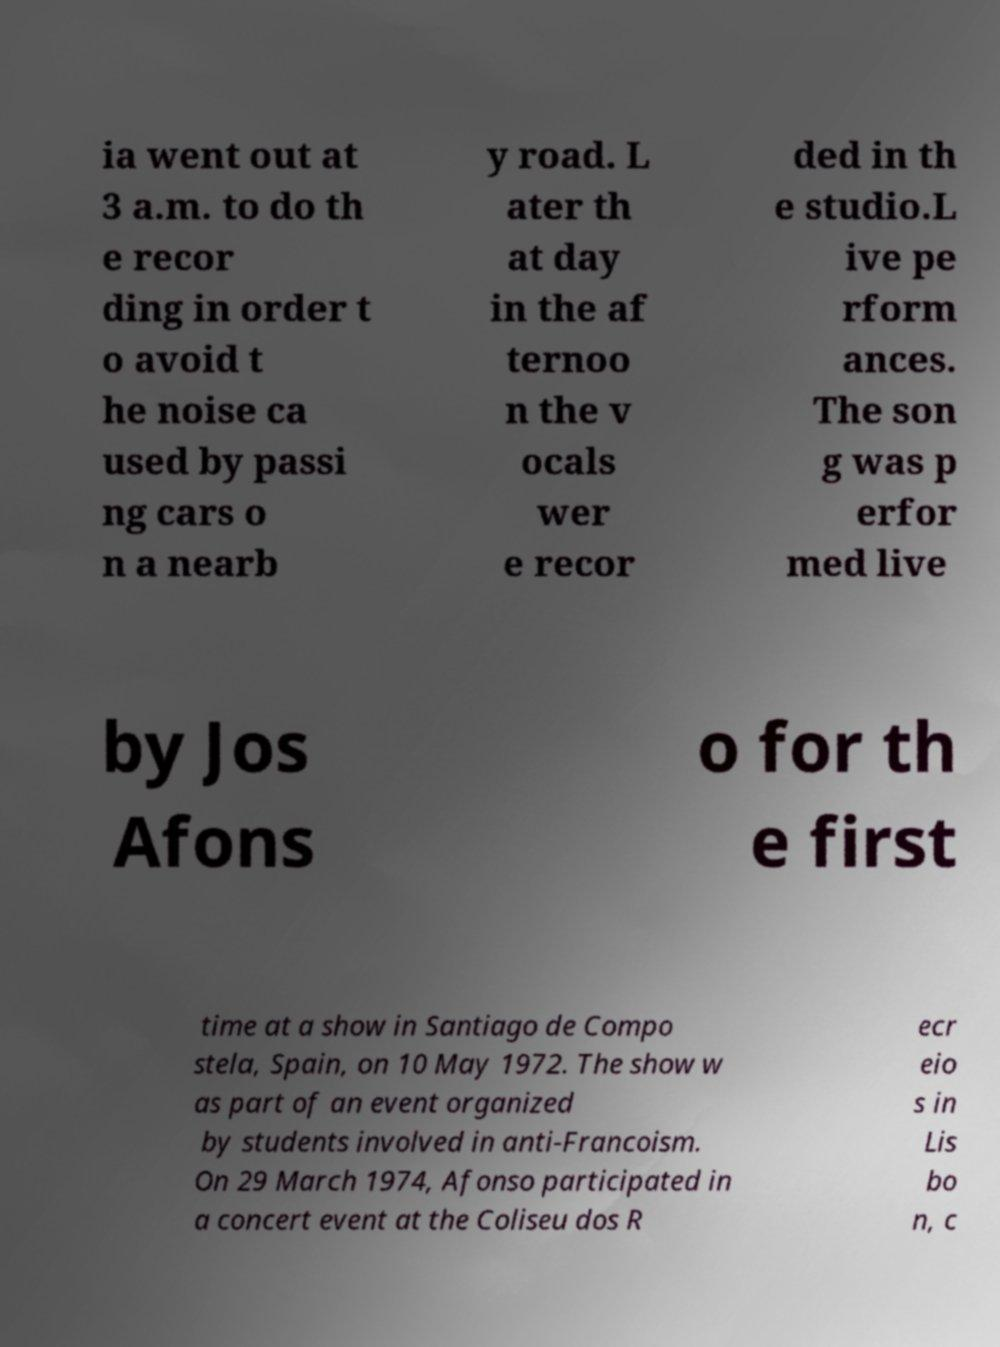Could you assist in decoding the text presented in this image and type it out clearly? ia went out at 3 a.m. to do th e recor ding in order t o avoid t he noise ca used by passi ng cars o n a nearb y road. L ater th at day in the af ternoo n the v ocals wer e recor ded in th e studio.L ive pe rform ances. The son g was p erfor med live by Jos Afons o for th e first time at a show in Santiago de Compo stela, Spain, on 10 May 1972. The show w as part of an event organized by students involved in anti-Francoism. On 29 March 1974, Afonso participated in a concert event at the Coliseu dos R ecr eio s in Lis bo n, c 